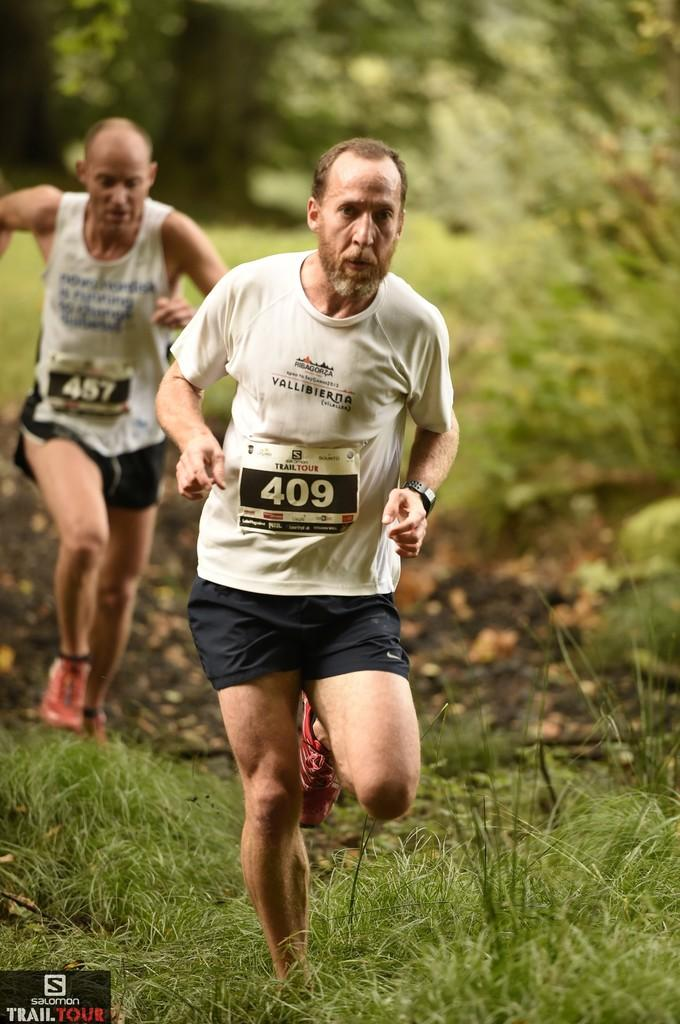How many people are present in the image? There are two people in the image. What are the people doing in the image? The people are running. What type of terrain is visible in the image? There is grass in the image. What can be seen in the background of the image? There are trees in the background of the image. What type of blade is being used by the people in the image? There is no blade visible in the image; the people are running without any tools or equipment. 